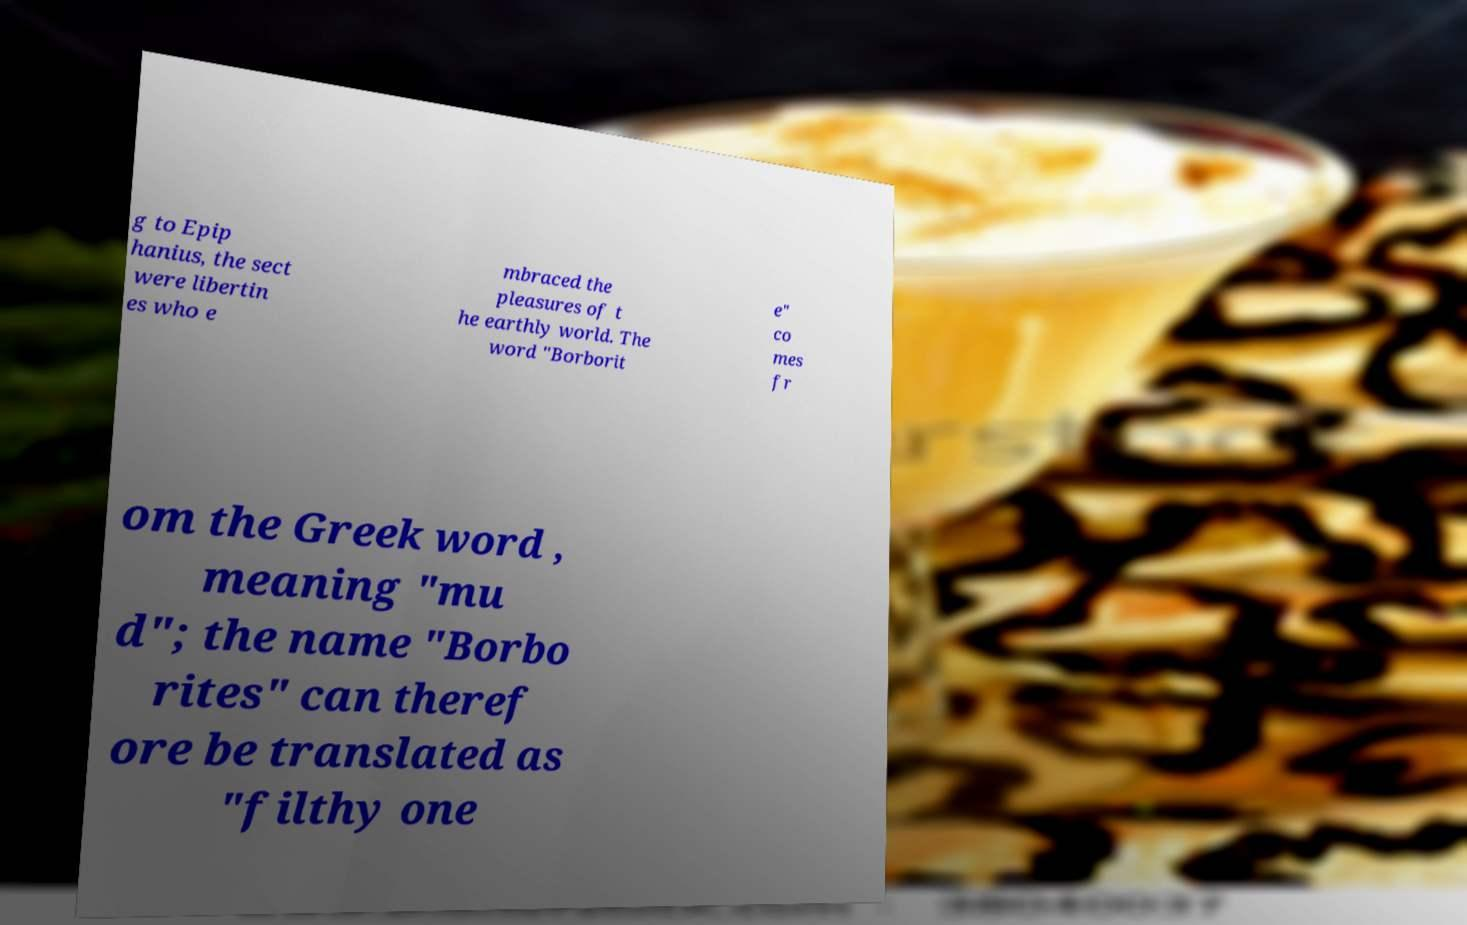Can you accurately transcribe the text from the provided image for me? g to Epip hanius, the sect were libertin es who e mbraced the pleasures of t he earthly world. The word "Borborit e" co mes fr om the Greek word , meaning "mu d"; the name "Borbo rites" can theref ore be translated as "filthy one 